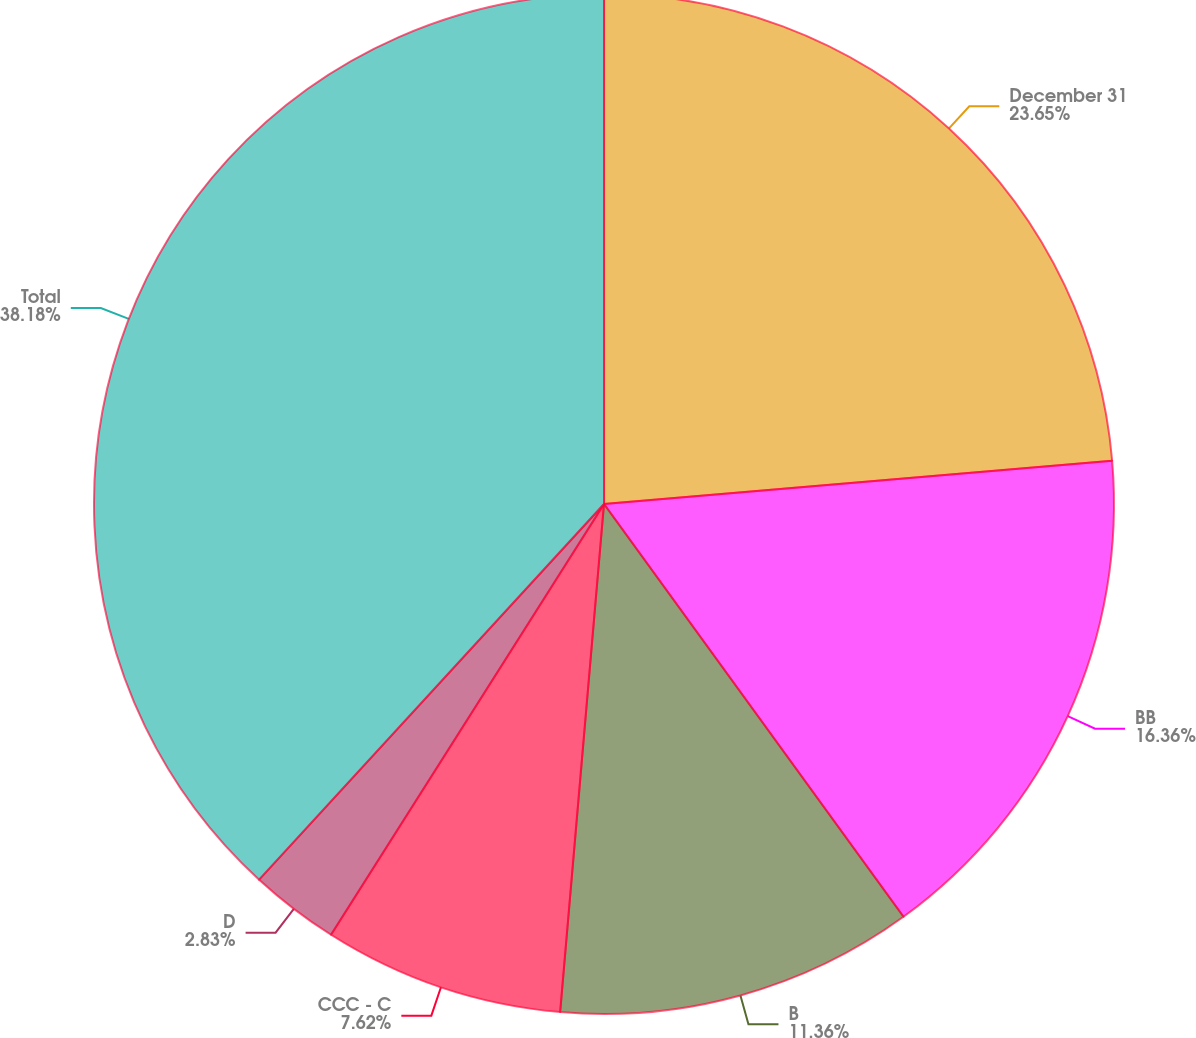Convert chart to OTSL. <chart><loc_0><loc_0><loc_500><loc_500><pie_chart><fcel>December 31<fcel>BB<fcel>B<fcel>CCC - C<fcel>D<fcel>Total<nl><fcel>23.65%<fcel>16.36%<fcel>11.36%<fcel>7.62%<fcel>2.83%<fcel>38.18%<nl></chart> 